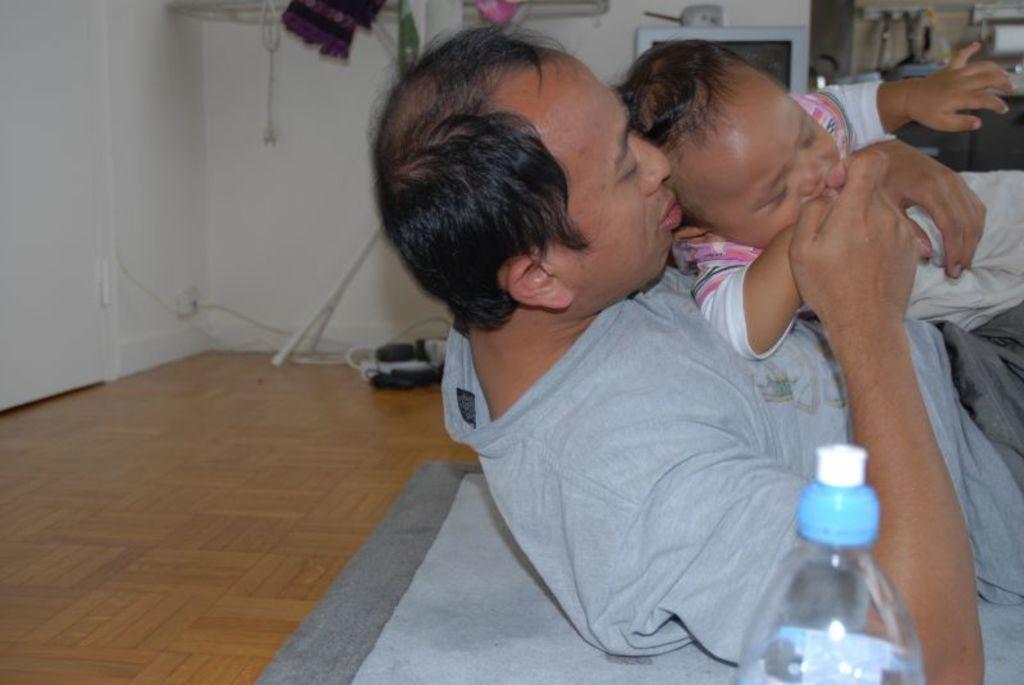Please provide a concise description of this image. As we can see in the image there is a white color wall, two people laying on floor and in the front there is a bottle. 